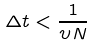<formula> <loc_0><loc_0><loc_500><loc_500>\Delta t < \frac { 1 } { \upsilon N }</formula> 